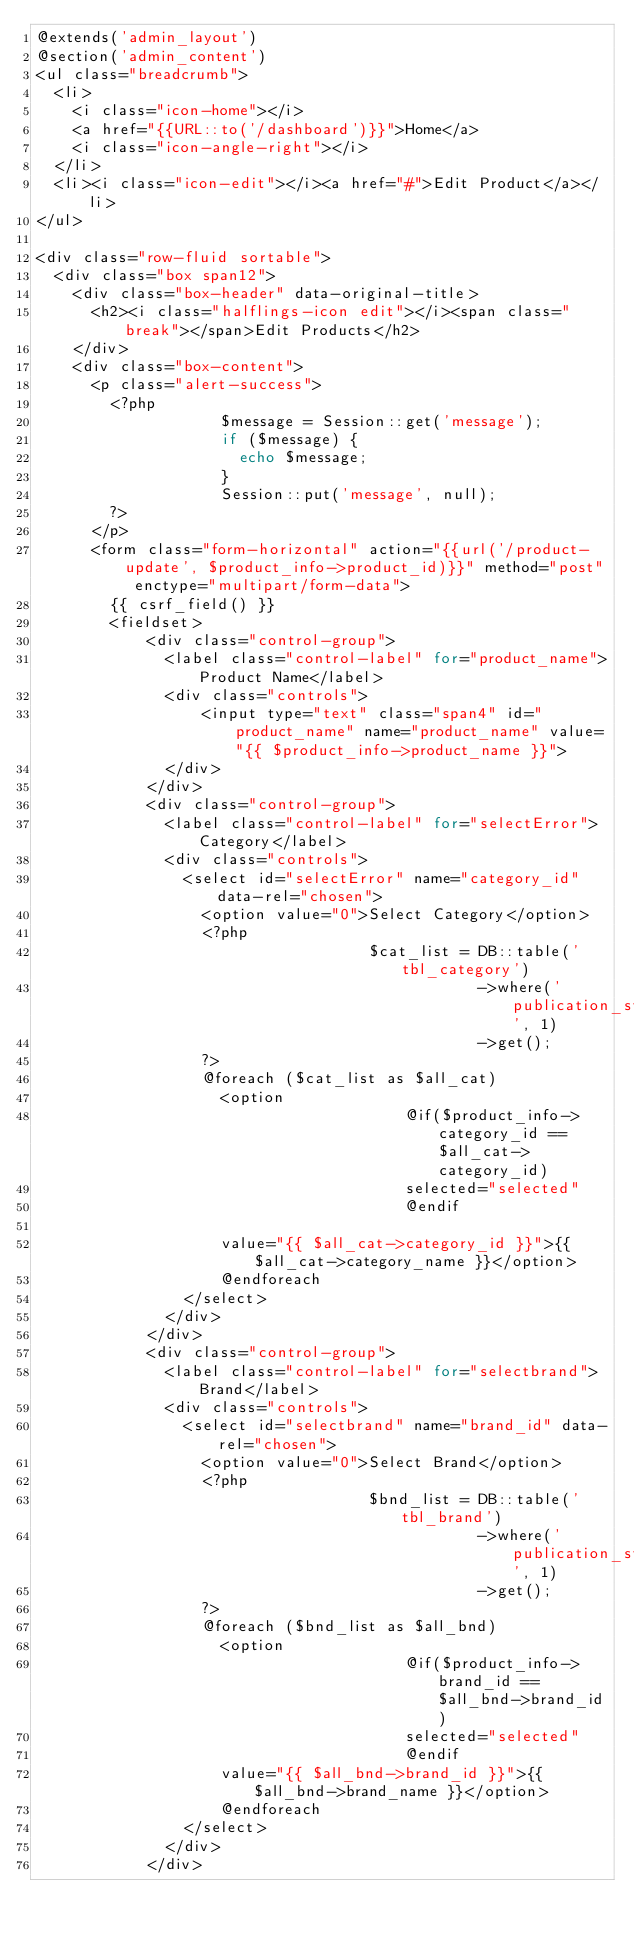<code> <loc_0><loc_0><loc_500><loc_500><_PHP_>@extends('admin_layout')
@section('admin_content')
<ul class="breadcrumb">
	<li>
		<i class="icon-home"></i>
		<a href="{{URL::to('/dashboard')}}">Home</a> 
		<i class="icon-angle-right"></i>
	</li>
	<li><i class="icon-edit"></i><a href="#">Edit Product</a></li>
</ul>

<div class="row-fluid sortable">
	<div class="box span12">
		<div class="box-header" data-original-title>
			<h2><i class="halflings-icon edit"></i><span class="break"></span>Edit Products</h2>
		</div>
		<div class="box-content">
			<p class="alert-success">
				<?php
                    $message = Session::get('message');
                    if ($message) {
                    	echo $message;
                    }
                    Session::put('message', null);
				?>
			</p>
			<form class="form-horizontal" action="{{url('/product-update', $product_info->product_id)}}" method="post" enctype="multipart/form-data">
				{{ csrf_field() }}
				<fieldset>
				    <div class="control-group">
					    <label class="control-label" for="product_name">Product Name</label>
					    <div class="controls">
					        <input type="text" class="span4" id="product_name" name="product_name" value="{{ $product_info->product_name }}">
					    </div>
				    </div>
				    <div class="control-group">
					    <label class="control-label" for="selectError">Category</label>
					    <div class="controls">
						    <select id="selectError" name="category_id" data-rel="chosen">
						    	<option value="0">Select Category</option>
						    	<?php
                                    $cat_list = DB::table('tbl_category')
                                                ->where('publication_status', 1)
                                                ->get();
						    	?>
						    	@foreach ($cat_list as $all_cat)
						        <option 
                                        @if($product_info->category_id == $all_cat->category_id)
                                        selected="selected" 
                                        @endif

						        value="{{ $all_cat->category_id }}">{{ $all_cat->category_name }}</option>
						        @endforeach
						    </select>
					    </div>
				    </div>	    
				    <div class="control-group">
					    <label class="control-label" for="selectbrand">Brand</label>
					    <div class="controls">
						    <select id="selectbrand" name="brand_id" data-rel="chosen">
						    	<option value="0">Select Brand</option>
						    	<?php
                                    $bnd_list = DB::table('tbl_brand')
                                                ->where('publication_status', 1)
                                                ->get();
						    	?>
						    	@foreach ($bnd_list as $all_bnd)
						        <option 
                                        @if($product_info->brand_id == $all_bnd->brand_id)
                                        selected="selected" 
                                        @endif
						        value="{{ $all_bnd->brand_id }}">{{ $all_bnd->brand_name }}</option>
						        @endforeach
						    </select>
					    </div>
				    </div></code> 